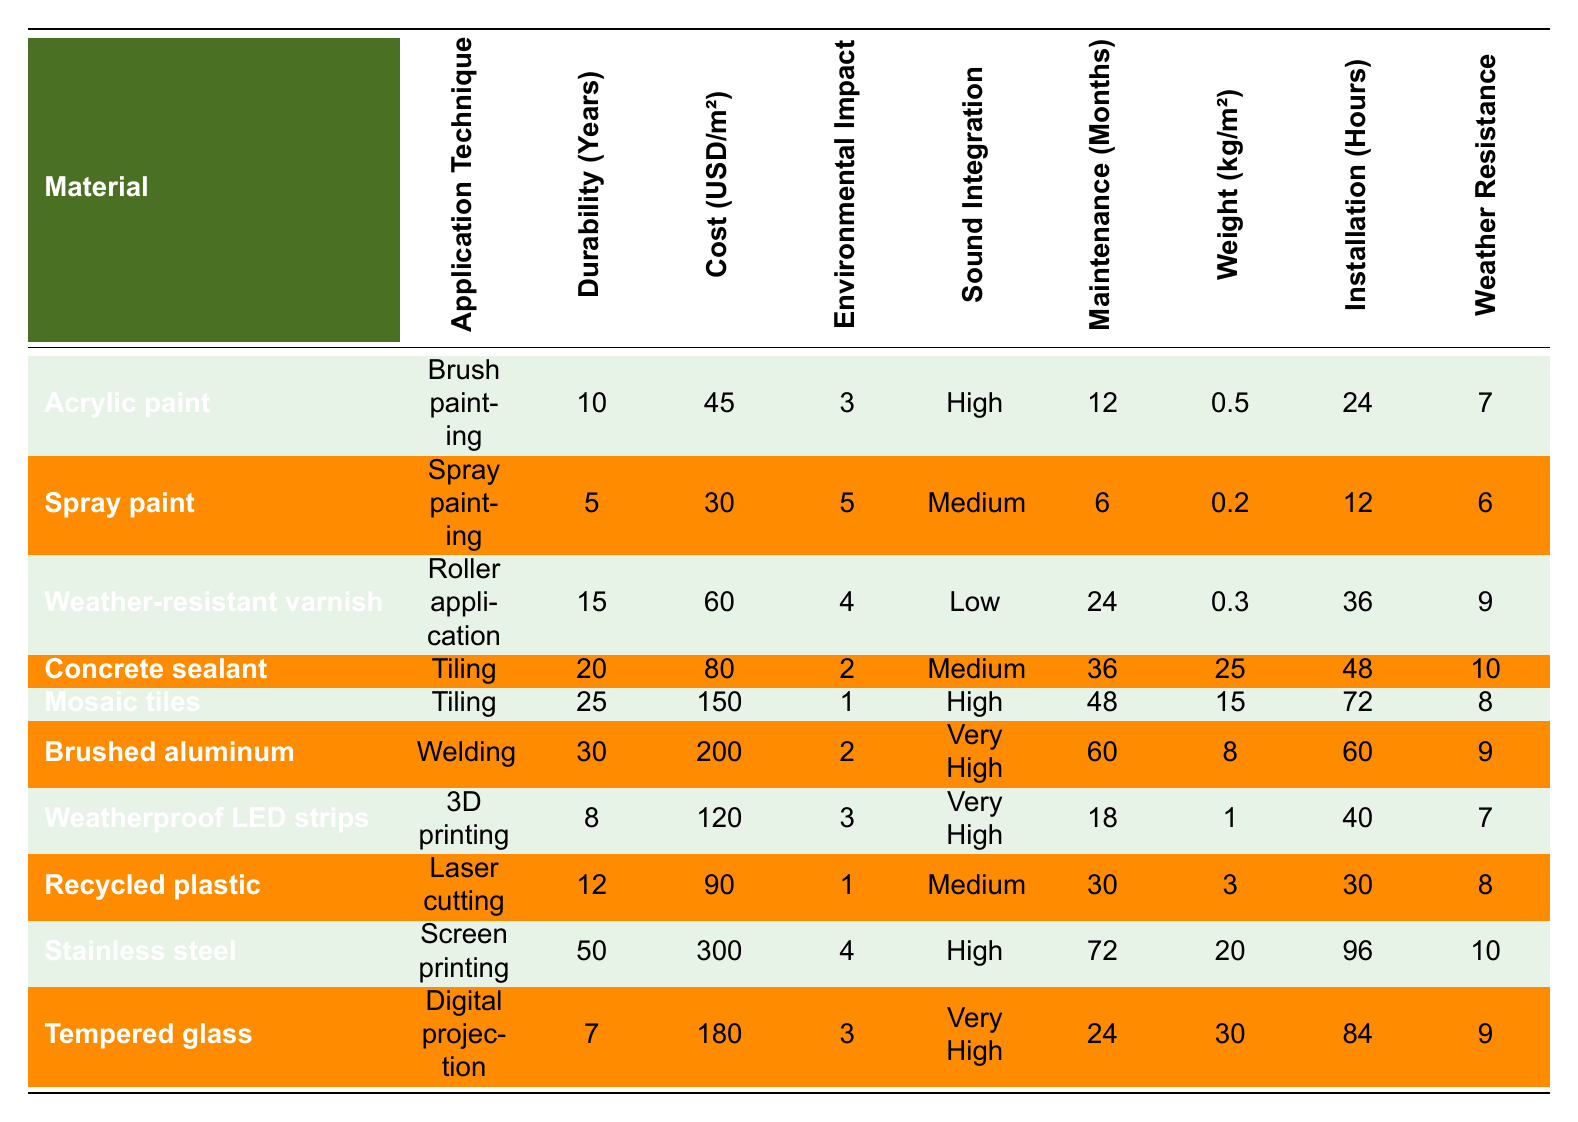What is the durability of mosaic tiles? The table lists the durability of mosaic tiles under the "Durability (Years)" column, showing it as 25 years.
Answer: 25 years Which material has the highest cost per square meter? By examining the "Cost (USD/m²)" column, stainless steel is listed with the highest cost of 300 USD/m².
Answer: 300 USD What is the environmental impact score of weather-resistant varnish? Looking at the "Environmental Impact" column, weather-resistant varnish has a score of 4.
Answer: 4 What materials have a high possibility of sound integration? The "Sound Integration" column indicates that acrylic paint, mosaic tiles, stainless steel, and both weatherproof LED strips and tempered glass have "High" or "Very High" ratings.
Answer: Acrylic paint, mosaic tiles, stainless steel, weatherproof LED strips, tempered glass Which application technique requires the most installation time? By reviewing the "Installation (Hours)" column, we find that stainless steel takes the most time, requiring 96 hours for installation.
Answer: 96 hours Is the maintenance frequency for concrete sealant less than 30 months? The "Maintenance (Months)" column shows that concrete sealant requires 36 months, which is greater than 30. Therefore, the answer is no.
Answer: No What is the average weight per square meter of the materials listed? To find the average, we sum all weights: (0.5 + 0.2 + 0.3 + 25 + 15 + 8 + 1 + 3 + 20 + 30) = 103.5 kg, then divide by 10 (the number of materials) to get the average: 103.5/10 = 10.35 kg/m².
Answer: 10.35 kg/m² Which material is the most durable, and what is its durability? By checking the "Durability (Years)" column, stainless steel stands out with the highest durability of 50 years.
Answer: Stainless steel, 50 years What is the relationship between weather resistance rating and installation time? Analyzing the "Weather Resistance" and "Installation (Hours)" columns shows that both high and low weather resistance ratings do not correlate with shorter or longer installation times due to varying techniques and weights.
Answer: No clear relationship Which material has the lowest environmental impact score? The "Environmental Impact" column reveals that mosaic tiles have the lowest score of 1.
Answer: 1 